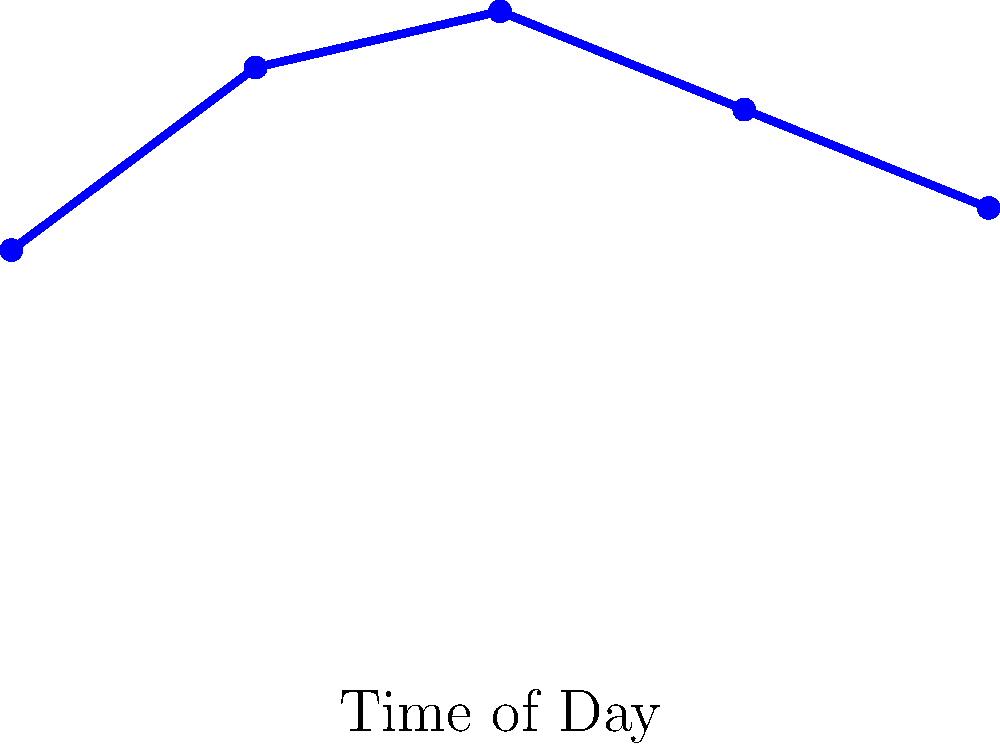Based on the engagement rate chart for press releases, which time of day would you recommend sending out press releases to maximize engagement? To determine the best time to send press releases, we need to analyze the engagement rate chart:

1. The chart shows engagement rates at different times of the day.
2. The x-axis represents the time of day, from 9:00 to 17:00 (5 PM).
3. The y-axis represents the engagement rate as a percentage.
4. We can see that the engagement rate varies throughout the day.
5. The data points are:
   - 9:00: 2.5%
   - 11:00: 3.8%
   - 13:00: 4.2%
   - 15:00: 3.5%
   - 17:00: 2.8%
6. The highest point on the graph corresponds to 13:00 (1 PM) with an engagement rate of 4.2%.
7. This suggests that sending press releases at 13:00 would likely result in the highest engagement.

Therefore, based on this data, the optimal time to send press releases to maximize engagement is at 13:00 (1 PM).
Answer: 13:00 (1 PM) 